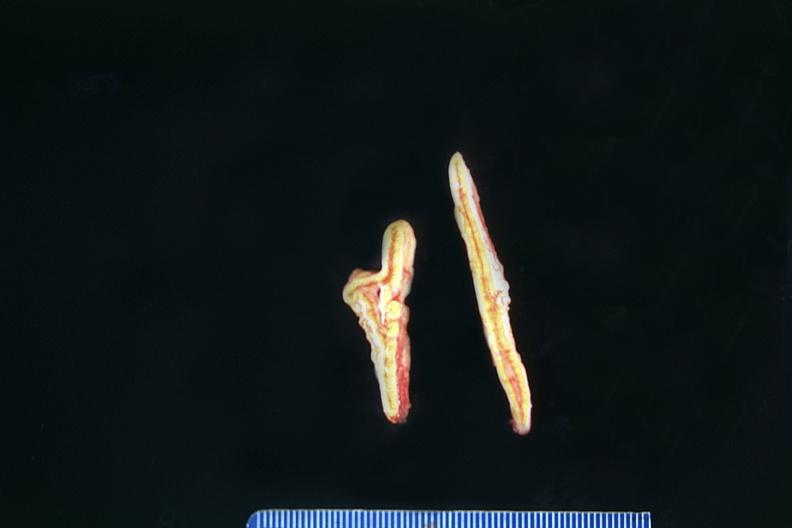what does this image show?
Answer the question using a single word or phrase. Adrenals 